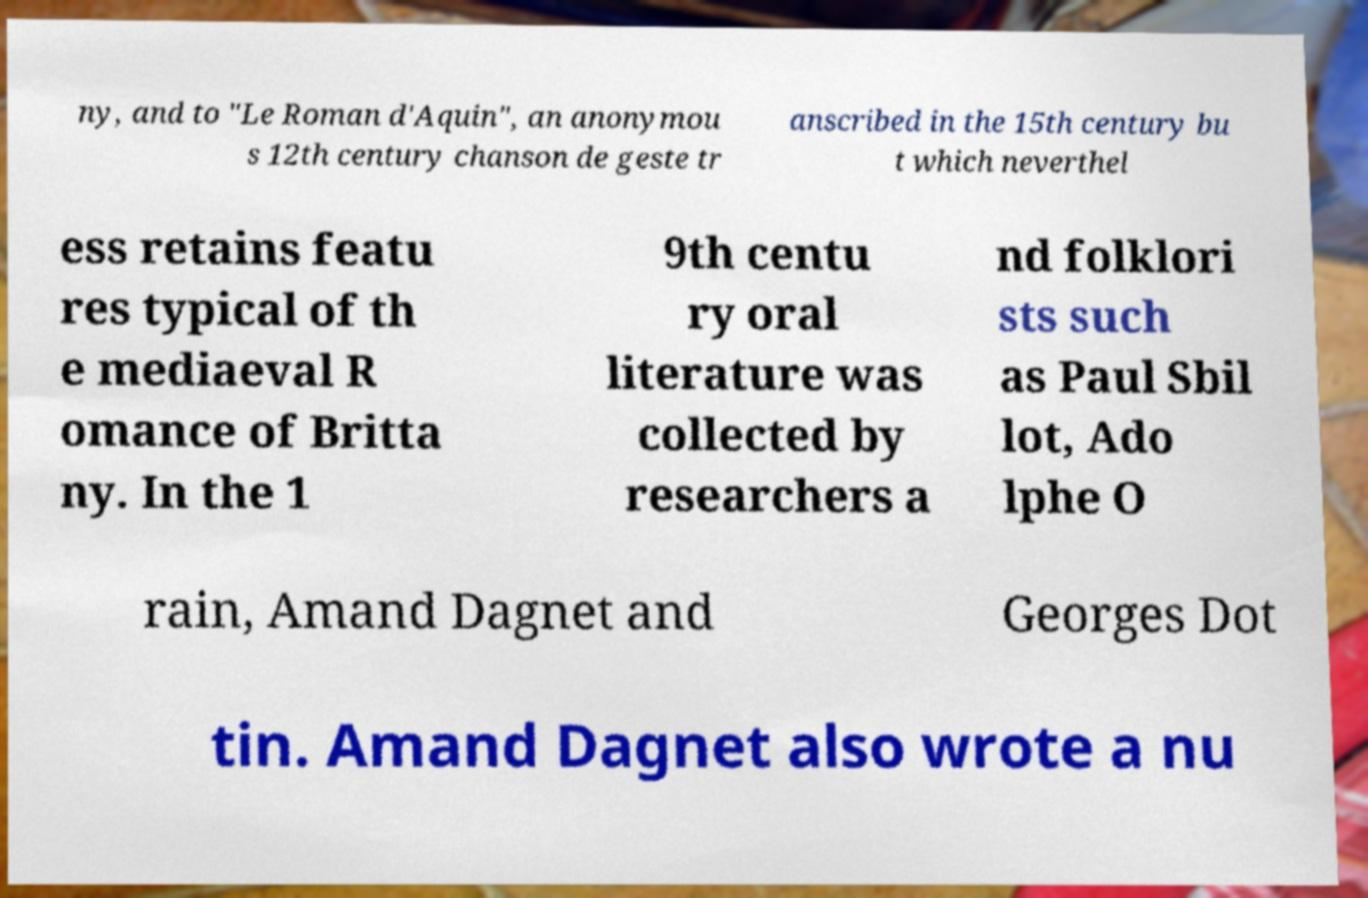Please read and relay the text visible in this image. What does it say? ny, and to "Le Roman d'Aquin", an anonymou s 12th century chanson de geste tr anscribed in the 15th century bu t which neverthel ess retains featu res typical of th e mediaeval R omance of Britta ny. In the 1 9th centu ry oral literature was collected by researchers a nd folklori sts such as Paul Sbil lot, Ado lphe O rain, Amand Dagnet and Georges Dot tin. Amand Dagnet also wrote a nu 